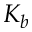Convert formula to latex. <formula><loc_0><loc_0><loc_500><loc_500>K _ { b }</formula> 